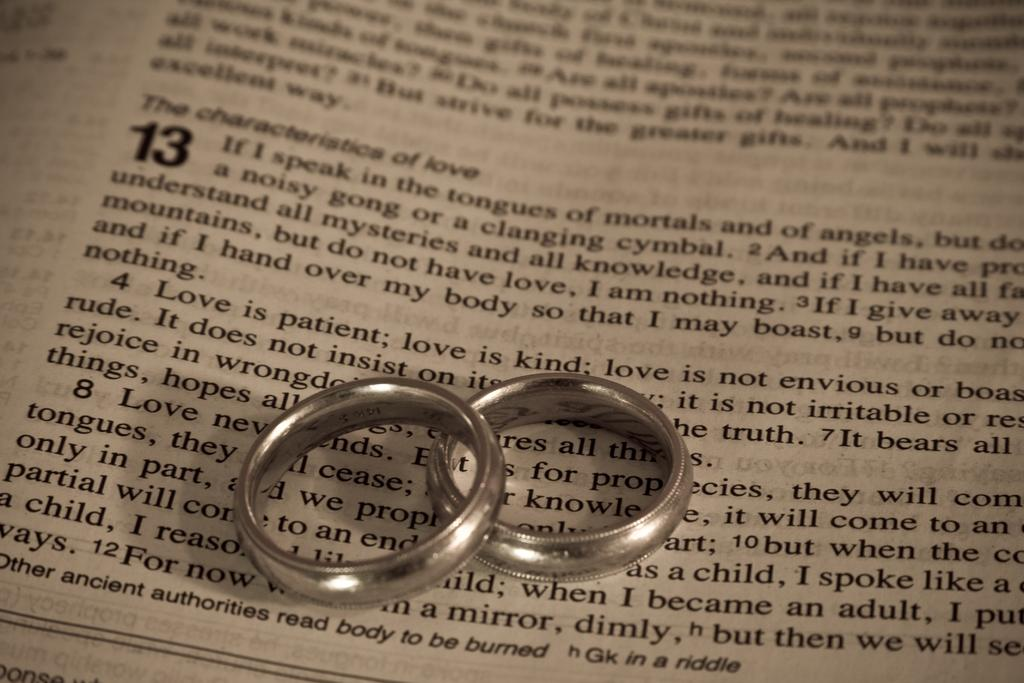<image>
Offer a succinct explanation of the picture presented. A Bible with two silver rings on top of it opened to chapter 13. 